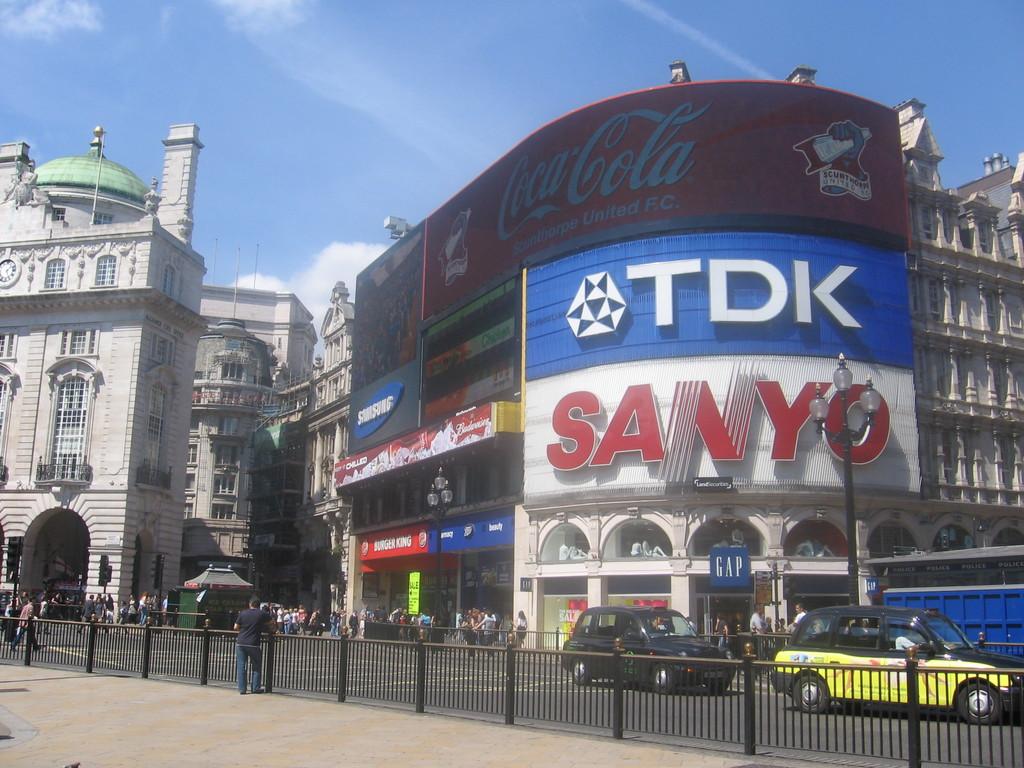What brand of soda is the top advertisement for?
Provide a succinct answer. Coca cola. 